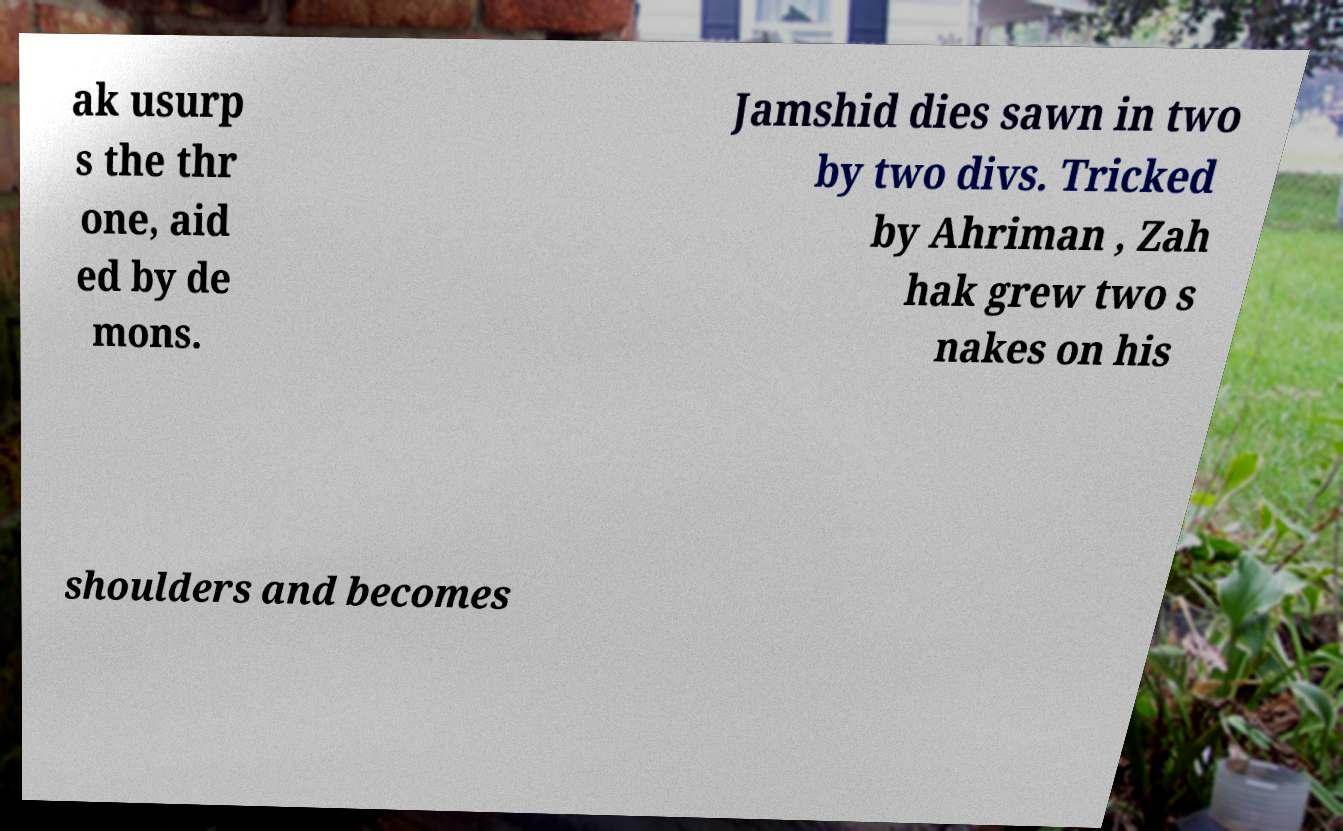Please read and relay the text visible in this image. What does it say? ak usurp s the thr one, aid ed by de mons. Jamshid dies sawn in two by two divs. Tricked by Ahriman , Zah hak grew two s nakes on his shoulders and becomes 